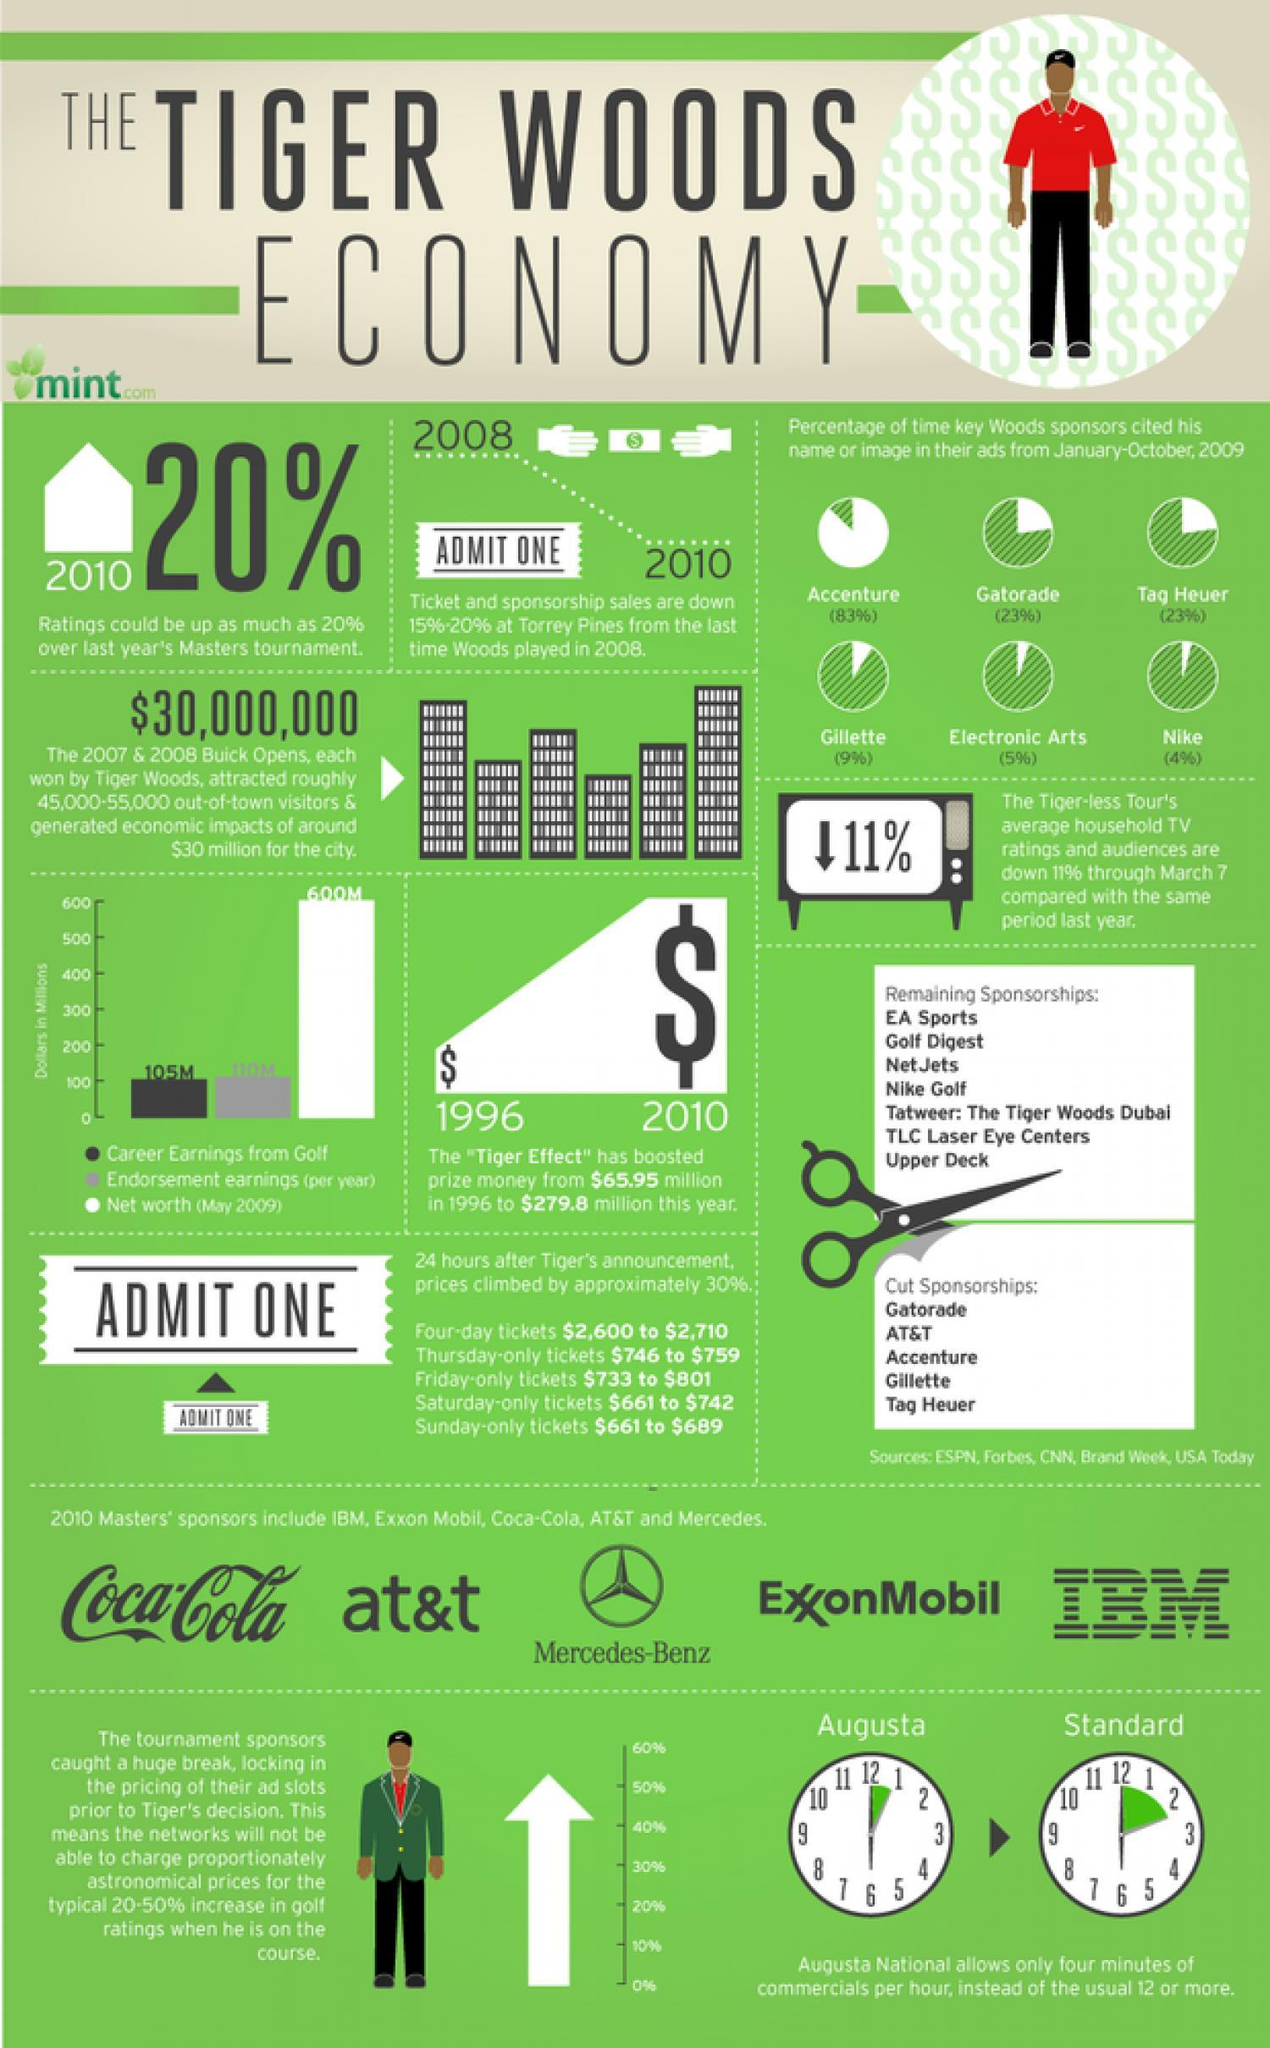How many master sponsors?
Answer the question with a short phrase. 5 How many clocks are in this infographic? 2 How many cut sponsorships? 5 How many remaining sponsorships? 7 